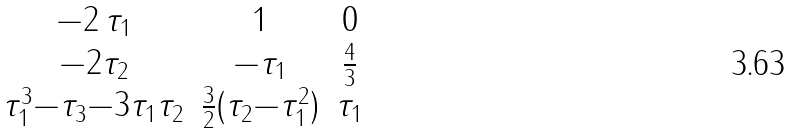Convert formula to latex. <formula><loc_0><loc_0><loc_500><loc_500>\begin{matrix} - 2 \, \tau _ { 1 } & 1 & 0 \\ - 2 \tau _ { 2 } & - \tau _ { 1 } & \frac { 4 } { 3 } \\ \tau _ { 1 } ^ { 3 } { - } \tau _ { 3 } { - } 3 \tau _ { 1 } \tau _ { 2 } & \frac { 3 } { 2 } ( \tau _ { 2 } { - } \tau _ { 1 } ^ { 2 } ) & \tau _ { 1 } \\ \end{matrix}</formula> 